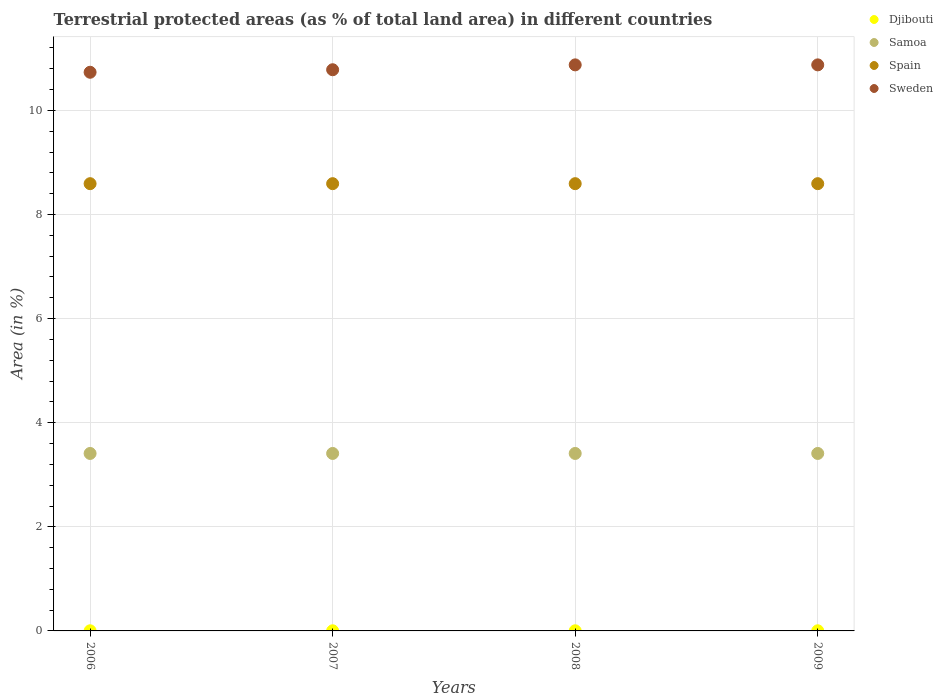What is the percentage of terrestrial protected land in Spain in 2007?
Your answer should be very brief. 8.59. Across all years, what is the maximum percentage of terrestrial protected land in Djibouti?
Keep it short and to the point. 0. Across all years, what is the minimum percentage of terrestrial protected land in Spain?
Ensure brevity in your answer.  8.59. In which year was the percentage of terrestrial protected land in Sweden maximum?
Keep it short and to the point. 2008. In which year was the percentage of terrestrial protected land in Spain minimum?
Your response must be concise. 2006. What is the total percentage of terrestrial protected land in Djibouti in the graph?
Your answer should be very brief. 0.01. What is the difference between the percentage of terrestrial protected land in Sweden in 2006 and that in 2009?
Provide a succinct answer. -0.14. What is the difference between the percentage of terrestrial protected land in Samoa in 2006 and the percentage of terrestrial protected land in Spain in 2008?
Provide a succinct answer. -5.18. What is the average percentage of terrestrial protected land in Samoa per year?
Keep it short and to the point. 3.41. In the year 2006, what is the difference between the percentage of terrestrial protected land in Djibouti and percentage of terrestrial protected land in Spain?
Ensure brevity in your answer.  -8.59. What is the difference between the highest and the lowest percentage of terrestrial protected land in Samoa?
Make the answer very short. 0. In how many years, is the percentage of terrestrial protected land in Spain greater than the average percentage of terrestrial protected land in Spain taken over all years?
Your answer should be very brief. 0. Is the sum of the percentage of terrestrial protected land in Djibouti in 2006 and 2007 greater than the maximum percentage of terrestrial protected land in Sweden across all years?
Make the answer very short. No. Is it the case that in every year, the sum of the percentage of terrestrial protected land in Samoa and percentage of terrestrial protected land in Sweden  is greater than the sum of percentage of terrestrial protected land in Djibouti and percentage of terrestrial protected land in Spain?
Provide a short and direct response. No. Is the percentage of terrestrial protected land in Djibouti strictly greater than the percentage of terrestrial protected land in Sweden over the years?
Your response must be concise. No. Is the percentage of terrestrial protected land in Spain strictly less than the percentage of terrestrial protected land in Samoa over the years?
Provide a succinct answer. No. How many years are there in the graph?
Offer a very short reply. 4. What is the difference between two consecutive major ticks on the Y-axis?
Make the answer very short. 2. Does the graph contain any zero values?
Make the answer very short. No. Where does the legend appear in the graph?
Make the answer very short. Top right. What is the title of the graph?
Offer a very short reply. Terrestrial protected areas (as % of total land area) in different countries. Does "Bermuda" appear as one of the legend labels in the graph?
Provide a succinct answer. No. What is the label or title of the X-axis?
Your response must be concise. Years. What is the label or title of the Y-axis?
Your response must be concise. Area (in %). What is the Area (in %) in Djibouti in 2006?
Ensure brevity in your answer.  0. What is the Area (in %) in Samoa in 2006?
Your answer should be compact. 3.41. What is the Area (in %) in Spain in 2006?
Your answer should be very brief. 8.59. What is the Area (in %) of Sweden in 2006?
Provide a succinct answer. 10.73. What is the Area (in %) of Djibouti in 2007?
Ensure brevity in your answer.  0. What is the Area (in %) of Samoa in 2007?
Provide a short and direct response. 3.41. What is the Area (in %) of Spain in 2007?
Your answer should be very brief. 8.59. What is the Area (in %) of Sweden in 2007?
Offer a very short reply. 10.78. What is the Area (in %) in Djibouti in 2008?
Make the answer very short. 0. What is the Area (in %) in Samoa in 2008?
Keep it short and to the point. 3.41. What is the Area (in %) of Spain in 2008?
Give a very brief answer. 8.59. What is the Area (in %) of Sweden in 2008?
Provide a succinct answer. 10.88. What is the Area (in %) of Djibouti in 2009?
Offer a terse response. 0. What is the Area (in %) of Samoa in 2009?
Your response must be concise. 3.41. What is the Area (in %) of Spain in 2009?
Keep it short and to the point. 8.59. What is the Area (in %) of Sweden in 2009?
Your response must be concise. 10.88. Across all years, what is the maximum Area (in %) of Djibouti?
Your answer should be compact. 0. Across all years, what is the maximum Area (in %) of Samoa?
Offer a very short reply. 3.41. Across all years, what is the maximum Area (in %) in Spain?
Your answer should be very brief. 8.59. Across all years, what is the maximum Area (in %) of Sweden?
Your response must be concise. 10.88. Across all years, what is the minimum Area (in %) in Djibouti?
Offer a very short reply. 0. Across all years, what is the minimum Area (in %) in Samoa?
Your answer should be very brief. 3.41. Across all years, what is the minimum Area (in %) of Spain?
Give a very brief answer. 8.59. Across all years, what is the minimum Area (in %) in Sweden?
Provide a short and direct response. 10.73. What is the total Area (in %) of Djibouti in the graph?
Your response must be concise. 0.01. What is the total Area (in %) of Samoa in the graph?
Offer a terse response. 13.64. What is the total Area (in %) in Spain in the graph?
Offer a very short reply. 34.37. What is the total Area (in %) in Sweden in the graph?
Provide a short and direct response. 43.27. What is the difference between the Area (in %) of Djibouti in 2006 and that in 2007?
Ensure brevity in your answer.  0. What is the difference between the Area (in %) of Sweden in 2006 and that in 2007?
Offer a terse response. -0.05. What is the difference between the Area (in %) in Djibouti in 2006 and that in 2008?
Keep it short and to the point. 0. What is the difference between the Area (in %) in Samoa in 2006 and that in 2008?
Keep it short and to the point. 0. What is the difference between the Area (in %) in Spain in 2006 and that in 2008?
Provide a succinct answer. 0. What is the difference between the Area (in %) of Sweden in 2006 and that in 2008?
Give a very brief answer. -0.14. What is the difference between the Area (in %) in Djibouti in 2006 and that in 2009?
Your answer should be compact. 0. What is the difference between the Area (in %) in Sweden in 2006 and that in 2009?
Your answer should be compact. -0.14. What is the difference between the Area (in %) in Samoa in 2007 and that in 2008?
Keep it short and to the point. 0. What is the difference between the Area (in %) of Sweden in 2007 and that in 2008?
Give a very brief answer. -0.09. What is the difference between the Area (in %) of Sweden in 2007 and that in 2009?
Your answer should be compact. -0.09. What is the difference between the Area (in %) of Djibouti in 2008 and that in 2009?
Provide a succinct answer. 0. What is the difference between the Area (in %) in Samoa in 2008 and that in 2009?
Make the answer very short. 0. What is the difference between the Area (in %) of Spain in 2008 and that in 2009?
Your response must be concise. 0. What is the difference between the Area (in %) in Sweden in 2008 and that in 2009?
Offer a terse response. 0. What is the difference between the Area (in %) of Djibouti in 2006 and the Area (in %) of Samoa in 2007?
Provide a short and direct response. -3.41. What is the difference between the Area (in %) in Djibouti in 2006 and the Area (in %) in Spain in 2007?
Offer a very short reply. -8.59. What is the difference between the Area (in %) in Djibouti in 2006 and the Area (in %) in Sweden in 2007?
Keep it short and to the point. -10.78. What is the difference between the Area (in %) of Samoa in 2006 and the Area (in %) of Spain in 2007?
Your answer should be compact. -5.18. What is the difference between the Area (in %) of Samoa in 2006 and the Area (in %) of Sweden in 2007?
Make the answer very short. -7.37. What is the difference between the Area (in %) in Spain in 2006 and the Area (in %) in Sweden in 2007?
Offer a very short reply. -2.19. What is the difference between the Area (in %) of Djibouti in 2006 and the Area (in %) of Samoa in 2008?
Your answer should be compact. -3.41. What is the difference between the Area (in %) of Djibouti in 2006 and the Area (in %) of Spain in 2008?
Your answer should be very brief. -8.59. What is the difference between the Area (in %) in Djibouti in 2006 and the Area (in %) in Sweden in 2008?
Make the answer very short. -10.87. What is the difference between the Area (in %) of Samoa in 2006 and the Area (in %) of Spain in 2008?
Offer a very short reply. -5.18. What is the difference between the Area (in %) in Samoa in 2006 and the Area (in %) in Sweden in 2008?
Provide a short and direct response. -7.47. What is the difference between the Area (in %) in Spain in 2006 and the Area (in %) in Sweden in 2008?
Your answer should be compact. -2.28. What is the difference between the Area (in %) of Djibouti in 2006 and the Area (in %) of Samoa in 2009?
Your response must be concise. -3.41. What is the difference between the Area (in %) of Djibouti in 2006 and the Area (in %) of Spain in 2009?
Your response must be concise. -8.59. What is the difference between the Area (in %) in Djibouti in 2006 and the Area (in %) in Sweden in 2009?
Your answer should be compact. -10.87. What is the difference between the Area (in %) of Samoa in 2006 and the Area (in %) of Spain in 2009?
Provide a short and direct response. -5.18. What is the difference between the Area (in %) of Samoa in 2006 and the Area (in %) of Sweden in 2009?
Provide a succinct answer. -7.47. What is the difference between the Area (in %) of Spain in 2006 and the Area (in %) of Sweden in 2009?
Keep it short and to the point. -2.28. What is the difference between the Area (in %) in Djibouti in 2007 and the Area (in %) in Samoa in 2008?
Ensure brevity in your answer.  -3.41. What is the difference between the Area (in %) in Djibouti in 2007 and the Area (in %) in Spain in 2008?
Make the answer very short. -8.59. What is the difference between the Area (in %) of Djibouti in 2007 and the Area (in %) of Sweden in 2008?
Give a very brief answer. -10.87. What is the difference between the Area (in %) in Samoa in 2007 and the Area (in %) in Spain in 2008?
Give a very brief answer. -5.18. What is the difference between the Area (in %) of Samoa in 2007 and the Area (in %) of Sweden in 2008?
Provide a succinct answer. -7.47. What is the difference between the Area (in %) in Spain in 2007 and the Area (in %) in Sweden in 2008?
Keep it short and to the point. -2.28. What is the difference between the Area (in %) in Djibouti in 2007 and the Area (in %) in Samoa in 2009?
Keep it short and to the point. -3.41. What is the difference between the Area (in %) in Djibouti in 2007 and the Area (in %) in Spain in 2009?
Ensure brevity in your answer.  -8.59. What is the difference between the Area (in %) of Djibouti in 2007 and the Area (in %) of Sweden in 2009?
Your answer should be very brief. -10.87. What is the difference between the Area (in %) in Samoa in 2007 and the Area (in %) in Spain in 2009?
Your response must be concise. -5.18. What is the difference between the Area (in %) in Samoa in 2007 and the Area (in %) in Sweden in 2009?
Offer a terse response. -7.47. What is the difference between the Area (in %) of Spain in 2007 and the Area (in %) of Sweden in 2009?
Provide a short and direct response. -2.28. What is the difference between the Area (in %) of Djibouti in 2008 and the Area (in %) of Samoa in 2009?
Make the answer very short. -3.41. What is the difference between the Area (in %) of Djibouti in 2008 and the Area (in %) of Spain in 2009?
Offer a very short reply. -8.59. What is the difference between the Area (in %) in Djibouti in 2008 and the Area (in %) in Sweden in 2009?
Give a very brief answer. -10.87. What is the difference between the Area (in %) of Samoa in 2008 and the Area (in %) of Spain in 2009?
Ensure brevity in your answer.  -5.18. What is the difference between the Area (in %) of Samoa in 2008 and the Area (in %) of Sweden in 2009?
Provide a short and direct response. -7.47. What is the difference between the Area (in %) of Spain in 2008 and the Area (in %) of Sweden in 2009?
Provide a short and direct response. -2.28. What is the average Area (in %) of Djibouti per year?
Offer a terse response. 0. What is the average Area (in %) in Samoa per year?
Offer a very short reply. 3.41. What is the average Area (in %) in Spain per year?
Your answer should be compact. 8.59. What is the average Area (in %) in Sweden per year?
Ensure brevity in your answer.  10.82. In the year 2006, what is the difference between the Area (in %) in Djibouti and Area (in %) in Samoa?
Provide a succinct answer. -3.41. In the year 2006, what is the difference between the Area (in %) of Djibouti and Area (in %) of Spain?
Give a very brief answer. -8.59. In the year 2006, what is the difference between the Area (in %) of Djibouti and Area (in %) of Sweden?
Give a very brief answer. -10.73. In the year 2006, what is the difference between the Area (in %) in Samoa and Area (in %) in Spain?
Make the answer very short. -5.18. In the year 2006, what is the difference between the Area (in %) of Samoa and Area (in %) of Sweden?
Provide a succinct answer. -7.32. In the year 2006, what is the difference between the Area (in %) in Spain and Area (in %) in Sweden?
Offer a very short reply. -2.14. In the year 2007, what is the difference between the Area (in %) in Djibouti and Area (in %) in Samoa?
Provide a succinct answer. -3.41. In the year 2007, what is the difference between the Area (in %) of Djibouti and Area (in %) of Spain?
Offer a terse response. -8.59. In the year 2007, what is the difference between the Area (in %) in Djibouti and Area (in %) in Sweden?
Offer a terse response. -10.78. In the year 2007, what is the difference between the Area (in %) of Samoa and Area (in %) of Spain?
Provide a short and direct response. -5.18. In the year 2007, what is the difference between the Area (in %) in Samoa and Area (in %) in Sweden?
Your answer should be compact. -7.37. In the year 2007, what is the difference between the Area (in %) of Spain and Area (in %) of Sweden?
Provide a succinct answer. -2.19. In the year 2008, what is the difference between the Area (in %) in Djibouti and Area (in %) in Samoa?
Your response must be concise. -3.41. In the year 2008, what is the difference between the Area (in %) in Djibouti and Area (in %) in Spain?
Give a very brief answer. -8.59. In the year 2008, what is the difference between the Area (in %) of Djibouti and Area (in %) of Sweden?
Offer a very short reply. -10.87. In the year 2008, what is the difference between the Area (in %) in Samoa and Area (in %) in Spain?
Your answer should be compact. -5.18. In the year 2008, what is the difference between the Area (in %) of Samoa and Area (in %) of Sweden?
Your answer should be compact. -7.47. In the year 2008, what is the difference between the Area (in %) of Spain and Area (in %) of Sweden?
Ensure brevity in your answer.  -2.28. In the year 2009, what is the difference between the Area (in %) of Djibouti and Area (in %) of Samoa?
Ensure brevity in your answer.  -3.41. In the year 2009, what is the difference between the Area (in %) in Djibouti and Area (in %) in Spain?
Offer a very short reply. -8.59. In the year 2009, what is the difference between the Area (in %) in Djibouti and Area (in %) in Sweden?
Offer a very short reply. -10.87. In the year 2009, what is the difference between the Area (in %) of Samoa and Area (in %) of Spain?
Give a very brief answer. -5.18. In the year 2009, what is the difference between the Area (in %) in Samoa and Area (in %) in Sweden?
Your answer should be compact. -7.47. In the year 2009, what is the difference between the Area (in %) of Spain and Area (in %) of Sweden?
Keep it short and to the point. -2.28. What is the ratio of the Area (in %) of Djibouti in 2006 to that in 2007?
Provide a short and direct response. 1. What is the ratio of the Area (in %) of Samoa in 2006 to that in 2007?
Provide a short and direct response. 1. What is the ratio of the Area (in %) in Sweden in 2006 to that in 2007?
Offer a very short reply. 1. What is the ratio of the Area (in %) in Samoa in 2006 to that in 2008?
Ensure brevity in your answer.  1. What is the ratio of the Area (in %) in Spain in 2006 to that in 2008?
Your answer should be very brief. 1. What is the ratio of the Area (in %) of Sweden in 2006 to that in 2008?
Provide a short and direct response. 0.99. What is the ratio of the Area (in %) of Djibouti in 2006 to that in 2009?
Provide a short and direct response. 1. What is the ratio of the Area (in %) of Spain in 2006 to that in 2009?
Keep it short and to the point. 1. What is the ratio of the Area (in %) of Sweden in 2006 to that in 2009?
Your response must be concise. 0.99. What is the ratio of the Area (in %) in Samoa in 2007 to that in 2009?
Make the answer very short. 1. What is the ratio of the Area (in %) in Spain in 2007 to that in 2009?
Keep it short and to the point. 1. What is the ratio of the Area (in %) of Sweden in 2007 to that in 2009?
Your answer should be compact. 0.99. What is the ratio of the Area (in %) of Djibouti in 2008 to that in 2009?
Keep it short and to the point. 1. What is the ratio of the Area (in %) of Samoa in 2008 to that in 2009?
Offer a terse response. 1. What is the difference between the highest and the second highest Area (in %) of Djibouti?
Keep it short and to the point. 0. What is the difference between the highest and the second highest Area (in %) in Samoa?
Ensure brevity in your answer.  0. What is the difference between the highest and the second highest Area (in %) in Sweden?
Make the answer very short. 0. What is the difference between the highest and the lowest Area (in %) of Samoa?
Your answer should be compact. 0. What is the difference between the highest and the lowest Area (in %) in Sweden?
Your answer should be compact. 0.14. 